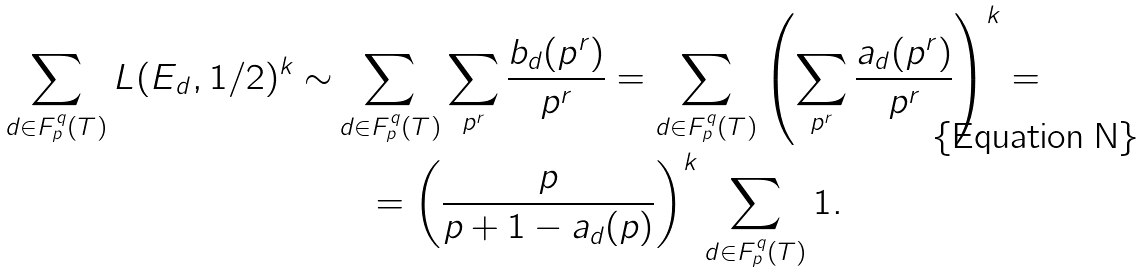<formula> <loc_0><loc_0><loc_500><loc_500>\sum _ { d \in F _ { p } ^ { q } ( T ) } L ( E _ { d } , 1 / 2 ) ^ { k } \sim & \sum _ { d \in F _ { p } ^ { q } ( T ) } \sum _ { p ^ { r } } \frac { b _ { d } ( p ^ { r } ) } { p ^ { r } } = \sum _ { d \in F _ { p } ^ { q } ( T ) } \left ( \sum _ { p ^ { r } } \frac { a _ { d } ( p ^ { r } ) } { p ^ { r } } \right ) ^ { k } = \\ & \quad = \left ( \frac { p } { p + 1 - a _ { d } ( p ) } \right ) ^ { k } \sum _ { d \in F _ { p } ^ { q } ( T ) } 1 . \\</formula> 